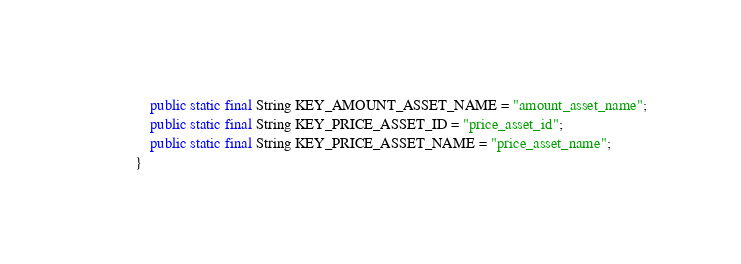<code> <loc_0><loc_0><loc_500><loc_500><_Java_>    public static final String KEY_AMOUNT_ASSET_NAME = "amount_asset_name";
    public static final String KEY_PRICE_ASSET_ID = "price_asset_id";
    public static final String KEY_PRICE_ASSET_NAME = "price_asset_name";
}
</code> 